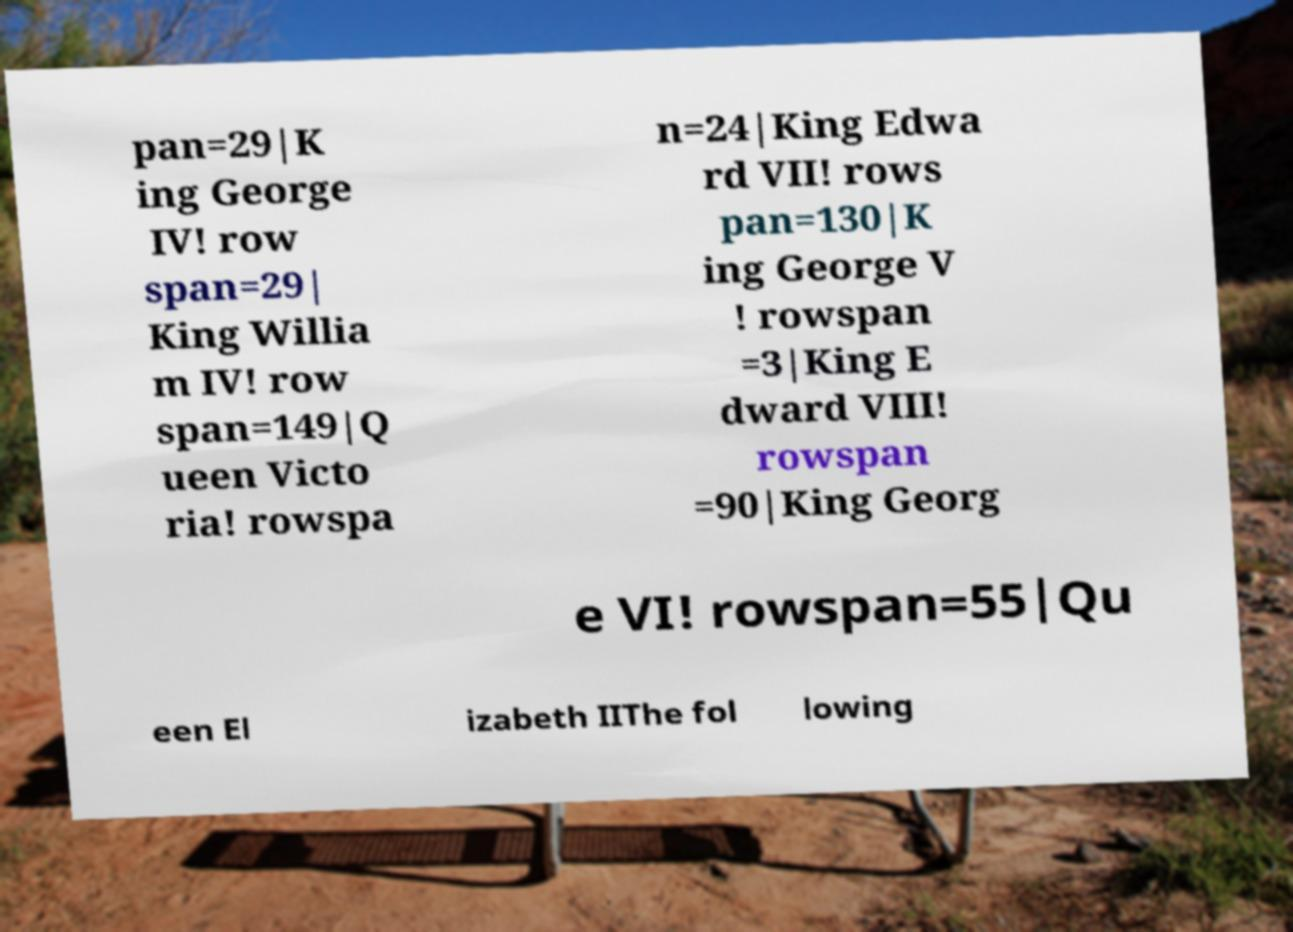Please read and relay the text visible in this image. What does it say? pan=29|K ing George IV! row span=29| King Willia m IV! row span=149|Q ueen Victo ria! rowspa n=24|King Edwa rd VII! rows pan=130|K ing George V ! rowspan =3|King E dward VIII! rowspan =90|King Georg e VI! rowspan=55|Qu een El izabeth IIThe fol lowing 